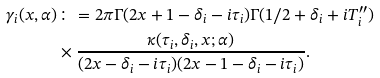<formula> <loc_0><loc_0><loc_500><loc_500>\gamma _ { i } ( x , \alpha ) & \colon = 2 \pi \Gamma ( 2 x + 1 - \delta _ { i } - i \tau _ { i } ) \Gamma ( 1 / 2 + \delta _ { i } + i T _ { i } ^ { \prime \prime } ) \\ & \times \frac { \kappa ( \tau _ { i } , \delta _ { i } , x ; \alpha ) } { ( 2 x - \delta _ { i } - i \tau _ { i } ) ( 2 x - 1 - \delta _ { i } - i \tau _ { i } ) } .</formula> 